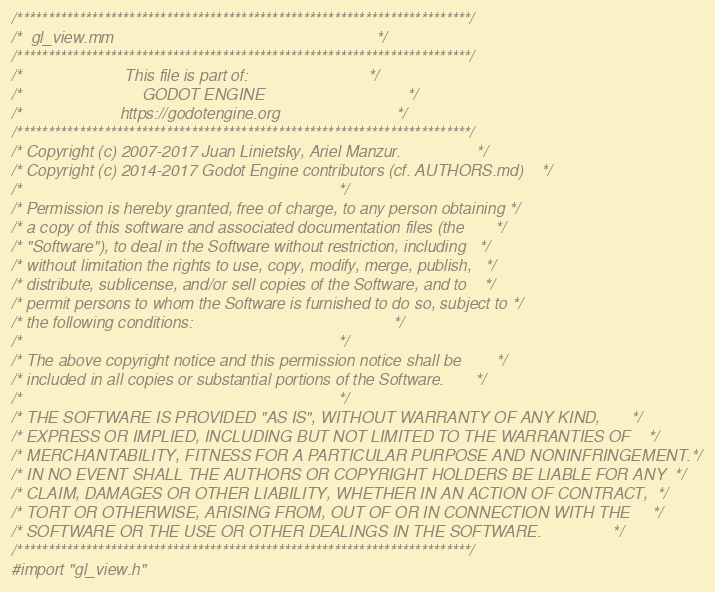Convert code to text. <code><loc_0><loc_0><loc_500><loc_500><_ObjectiveC_>/*************************************************************************/
/*  gl_view.mm                                                           */
/*************************************************************************/
/*                       This file is part of:                           */
/*                           GODOT ENGINE                                */
/*                      https://godotengine.org                          */
/*************************************************************************/
/* Copyright (c) 2007-2017 Juan Linietsky, Ariel Manzur.                 */
/* Copyright (c) 2014-2017 Godot Engine contributors (cf. AUTHORS.md)    */
/*                                                                       */
/* Permission is hereby granted, free of charge, to any person obtaining */
/* a copy of this software and associated documentation files (the       */
/* "Software"), to deal in the Software without restriction, including   */
/* without limitation the rights to use, copy, modify, merge, publish,   */
/* distribute, sublicense, and/or sell copies of the Software, and to    */
/* permit persons to whom the Software is furnished to do so, subject to */
/* the following conditions:                                             */
/*                                                                       */
/* The above copyright notice and this permission notice shall be        */
/* included in all copies or substantial portions of the Software.       */
/*                                                                       */
/* THE SOFTWARE IS PROVIDED "AS IS", WITHOUT WARRANTY OF ANY KIND,       */
/* EXPRESS OR IMPLIED, INCLUDING BUT NOT LIMITED TO THE WARRANTIES OF    */
/* MERCHANTABILITY, FITNESS FOR A PARTICULAR PURPOSE AND NONINFRINGEMENT.*/
/* IN NO EVENT SHALL THE AUTHORS OR COPYRIGHT HOLDERS BE LIABLE FOR ANY  */
/* CLAIM, DAMAGES OR OTHER LIABILITY, WHETHER IN AN ACTION OF CONTRACT,  */
/* TORT OR OTHERWISE, ARISING FROM, OUT OF OR IN CONNECTION WITH THE     */
/* SOFTWARE OR THE USE OR OTHER DEALINGS IN THE SOFTWARE.                */
/*************************************************************************/
#import "gl_view.h"
</code> 